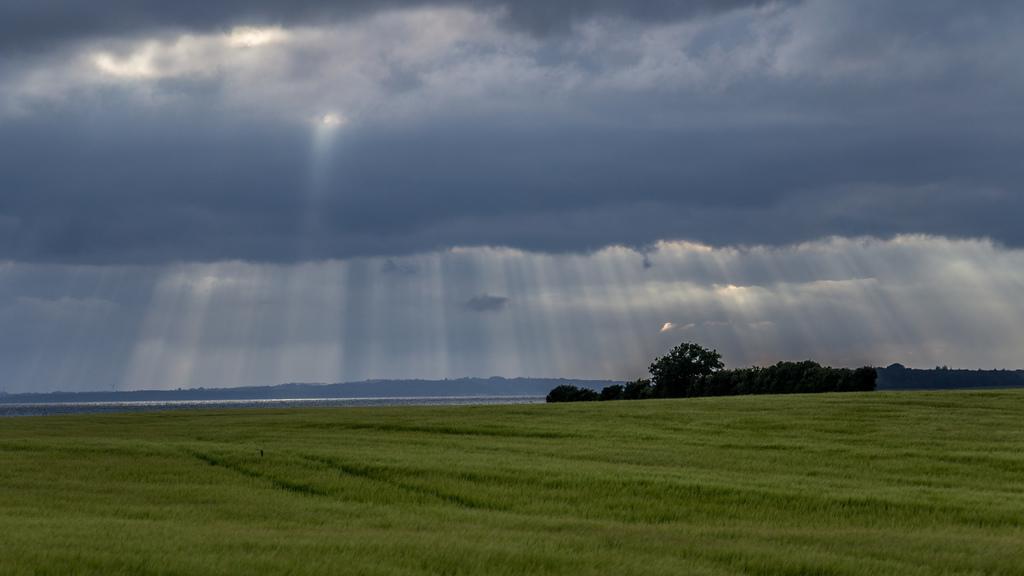How would you summarize this image in a sentence or two? In this image I can see grass, trees, mountains and the sky. This image is taken may be in a farm during a day. 